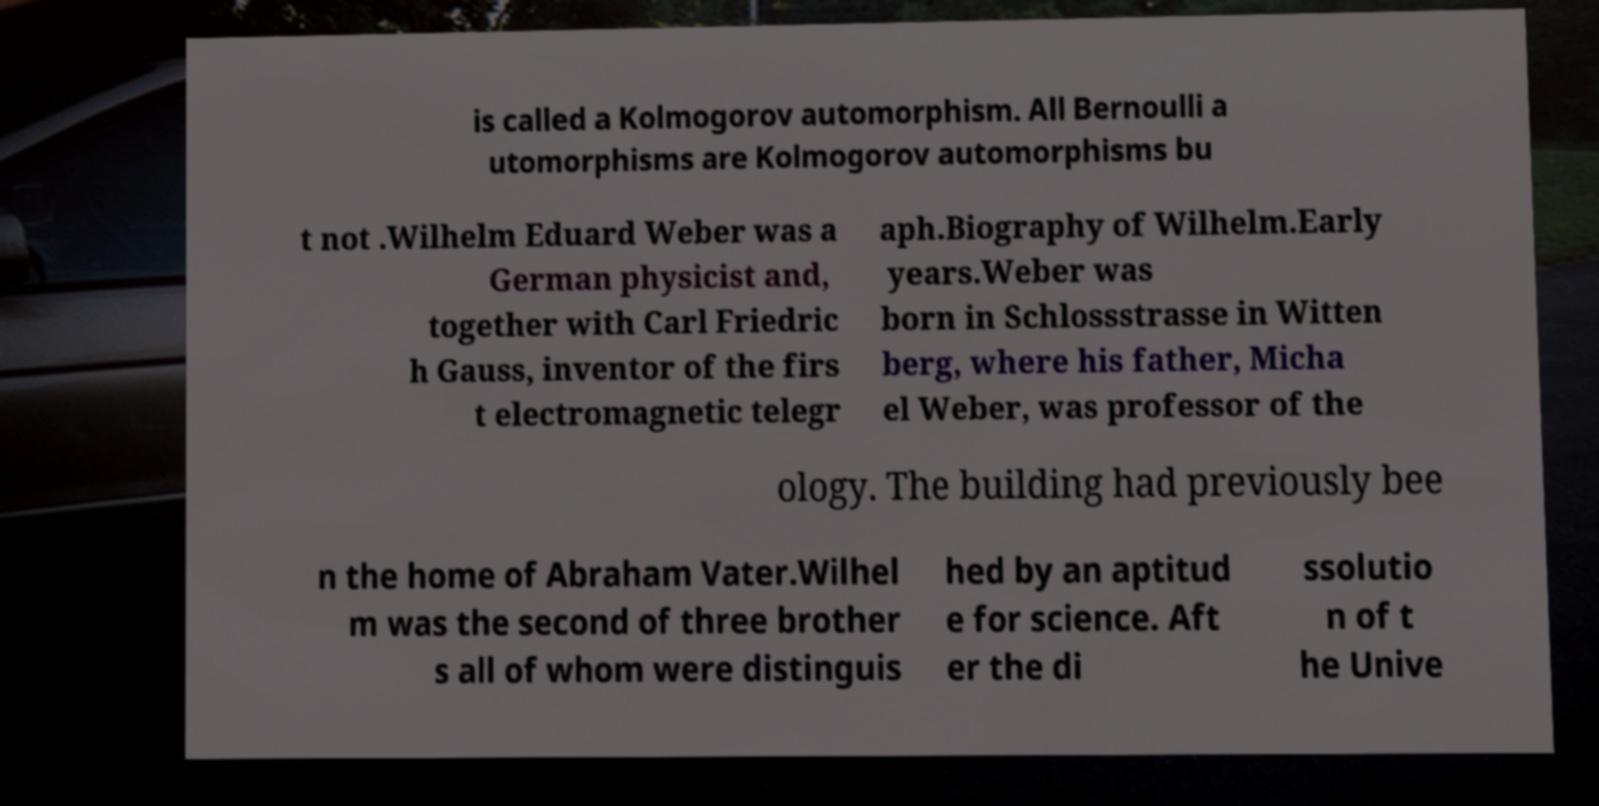Could you assist in decoding the text presented in this image and type it out clearly? is called a Kolmogorov automorphism. All Bernoulli a utomorphisms are Kolmogorov automorphisms bu t not .Wilhelm Eduard Weber was a German physicist and, together with Carl Friedric h Gauss, inventor of the firs t electromagnetic telegr aph.Biography of Wilhelm.Early years.Weber was born in Schlossstrasse in Witten berg, where his father, Micha el Weber, was professor of the ology. The building had previously bee n the home of Abraham Vater.Wilhel m was the second of three brother s all of whom were distinguis hed by an aptitud e for science. Aft er the di ssolutio n of t he Unive 